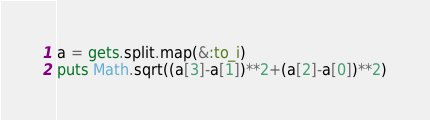Convert code to text. <code><loc_0><loc_0><loc_500><loc_500><_Ruby_>a = gets.split.map(&:to_i)
puts Math.sqrt((a[3]-a[1])**2+(a[2]-a[0])**2)</code> 